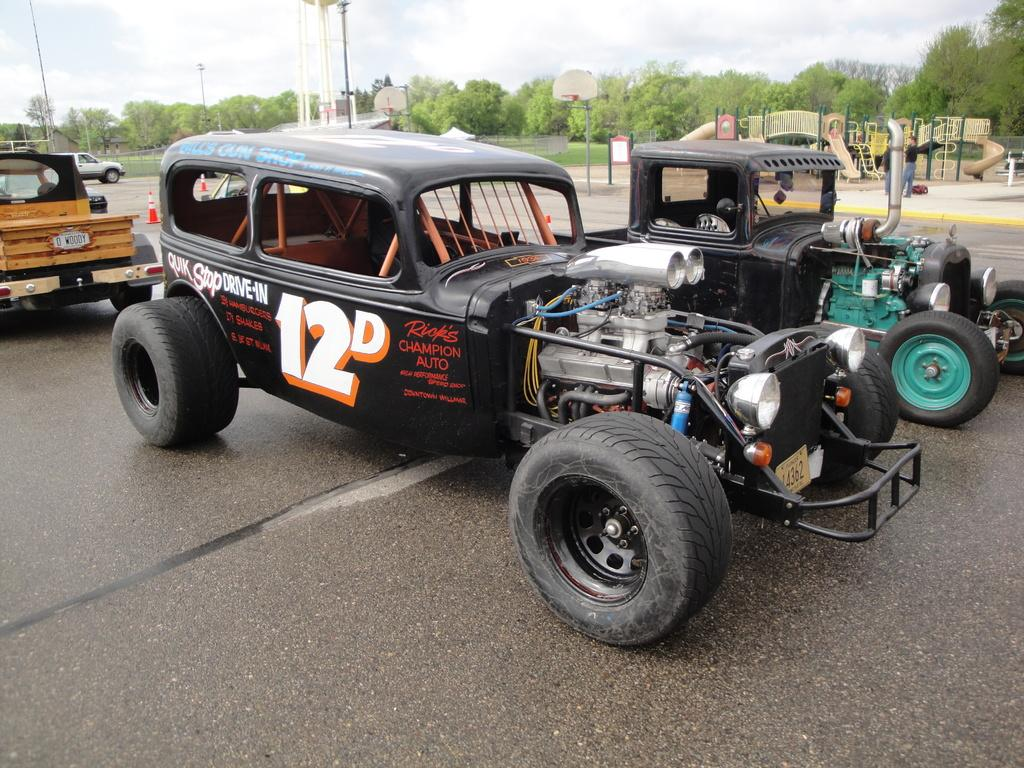What is happening on the road in the image? There are vehicles on the road in the image. What can be seen in the background of the image? The sky, clouds, trees, poles, sign boards, traffic poles, a fence, the road, and a play area are visible in the background of the image. What type of locket is hanging from the traffic pole in the image? There is no locket present in the image; the traffic pole is a part of the road infrastructure. 